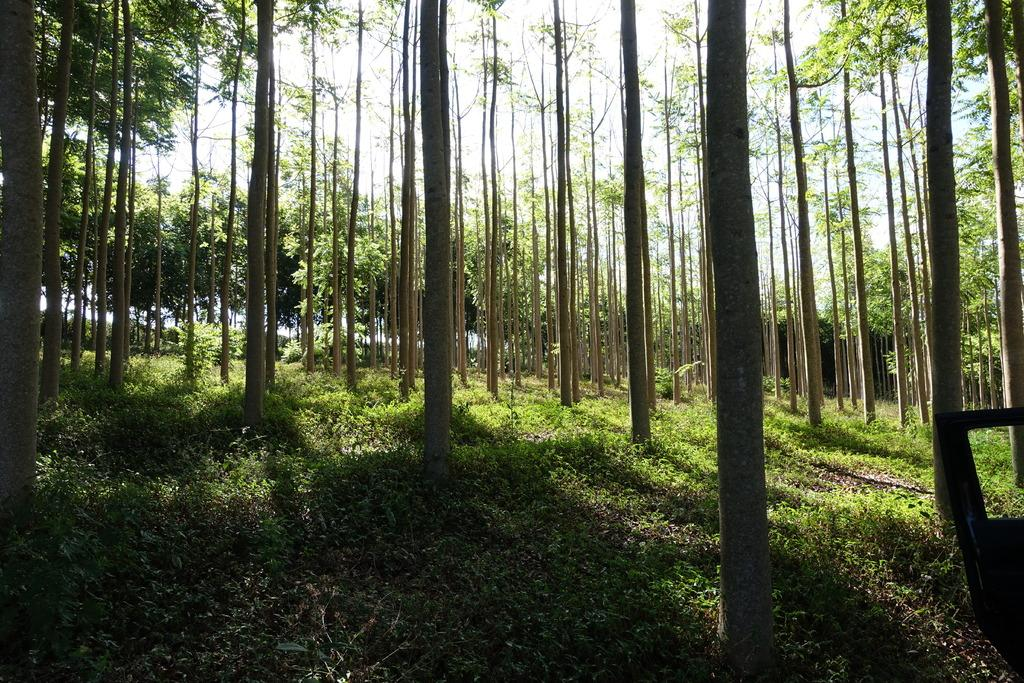What type of plant can be seen in the image? There is a tree in the image. Where is the tree located in relation to the image? The tree is located at the front of the image. What type of vegetation is on the ground in the image? There is grass on the ground in the image. Where is the grass located in relation to the image? The grass is located in the center of the image. What else can be seen in the background of the image? There are trees in the background of the image. What type of property does the servant own in the image? There is no mention of a servant or property in the image; it features a tree, grass, and additional trees in the background. 